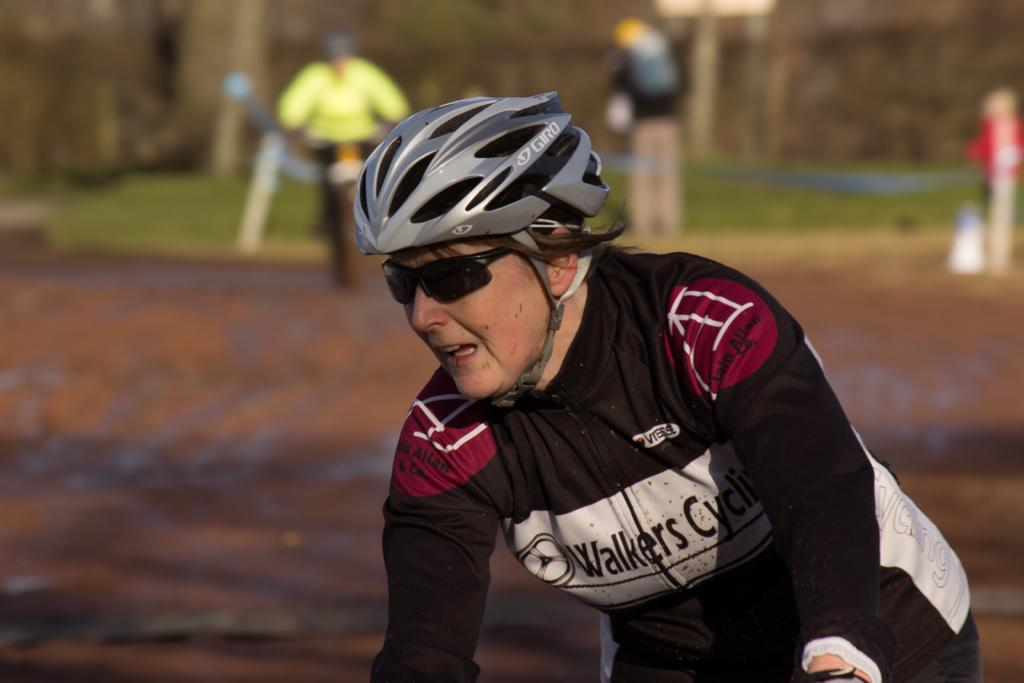What is the main subject of the image? There is a woman in the image. What is the woman wearing? The woman is wearing a black jacket. Who else is present in the image? There is another person in the image. What is the other person wearing? The other person is wearing a green dress. What is the other person doing in the image? The other person is riding a bicycle. How are the woman and the person on the bicycle positioned in the image? The woman is in front of the person riding the bicycle. What type of cherry is the woman holding in the image? There is no cherry present in the image. What decision does the person on the bicycle make in the image? There is no indication of a decision being made in the image. 